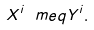<formula> <loc_0><loc_0><loc_500><loc_500>X ^ { i } \ m e q Y ^ { i } .</formula> 